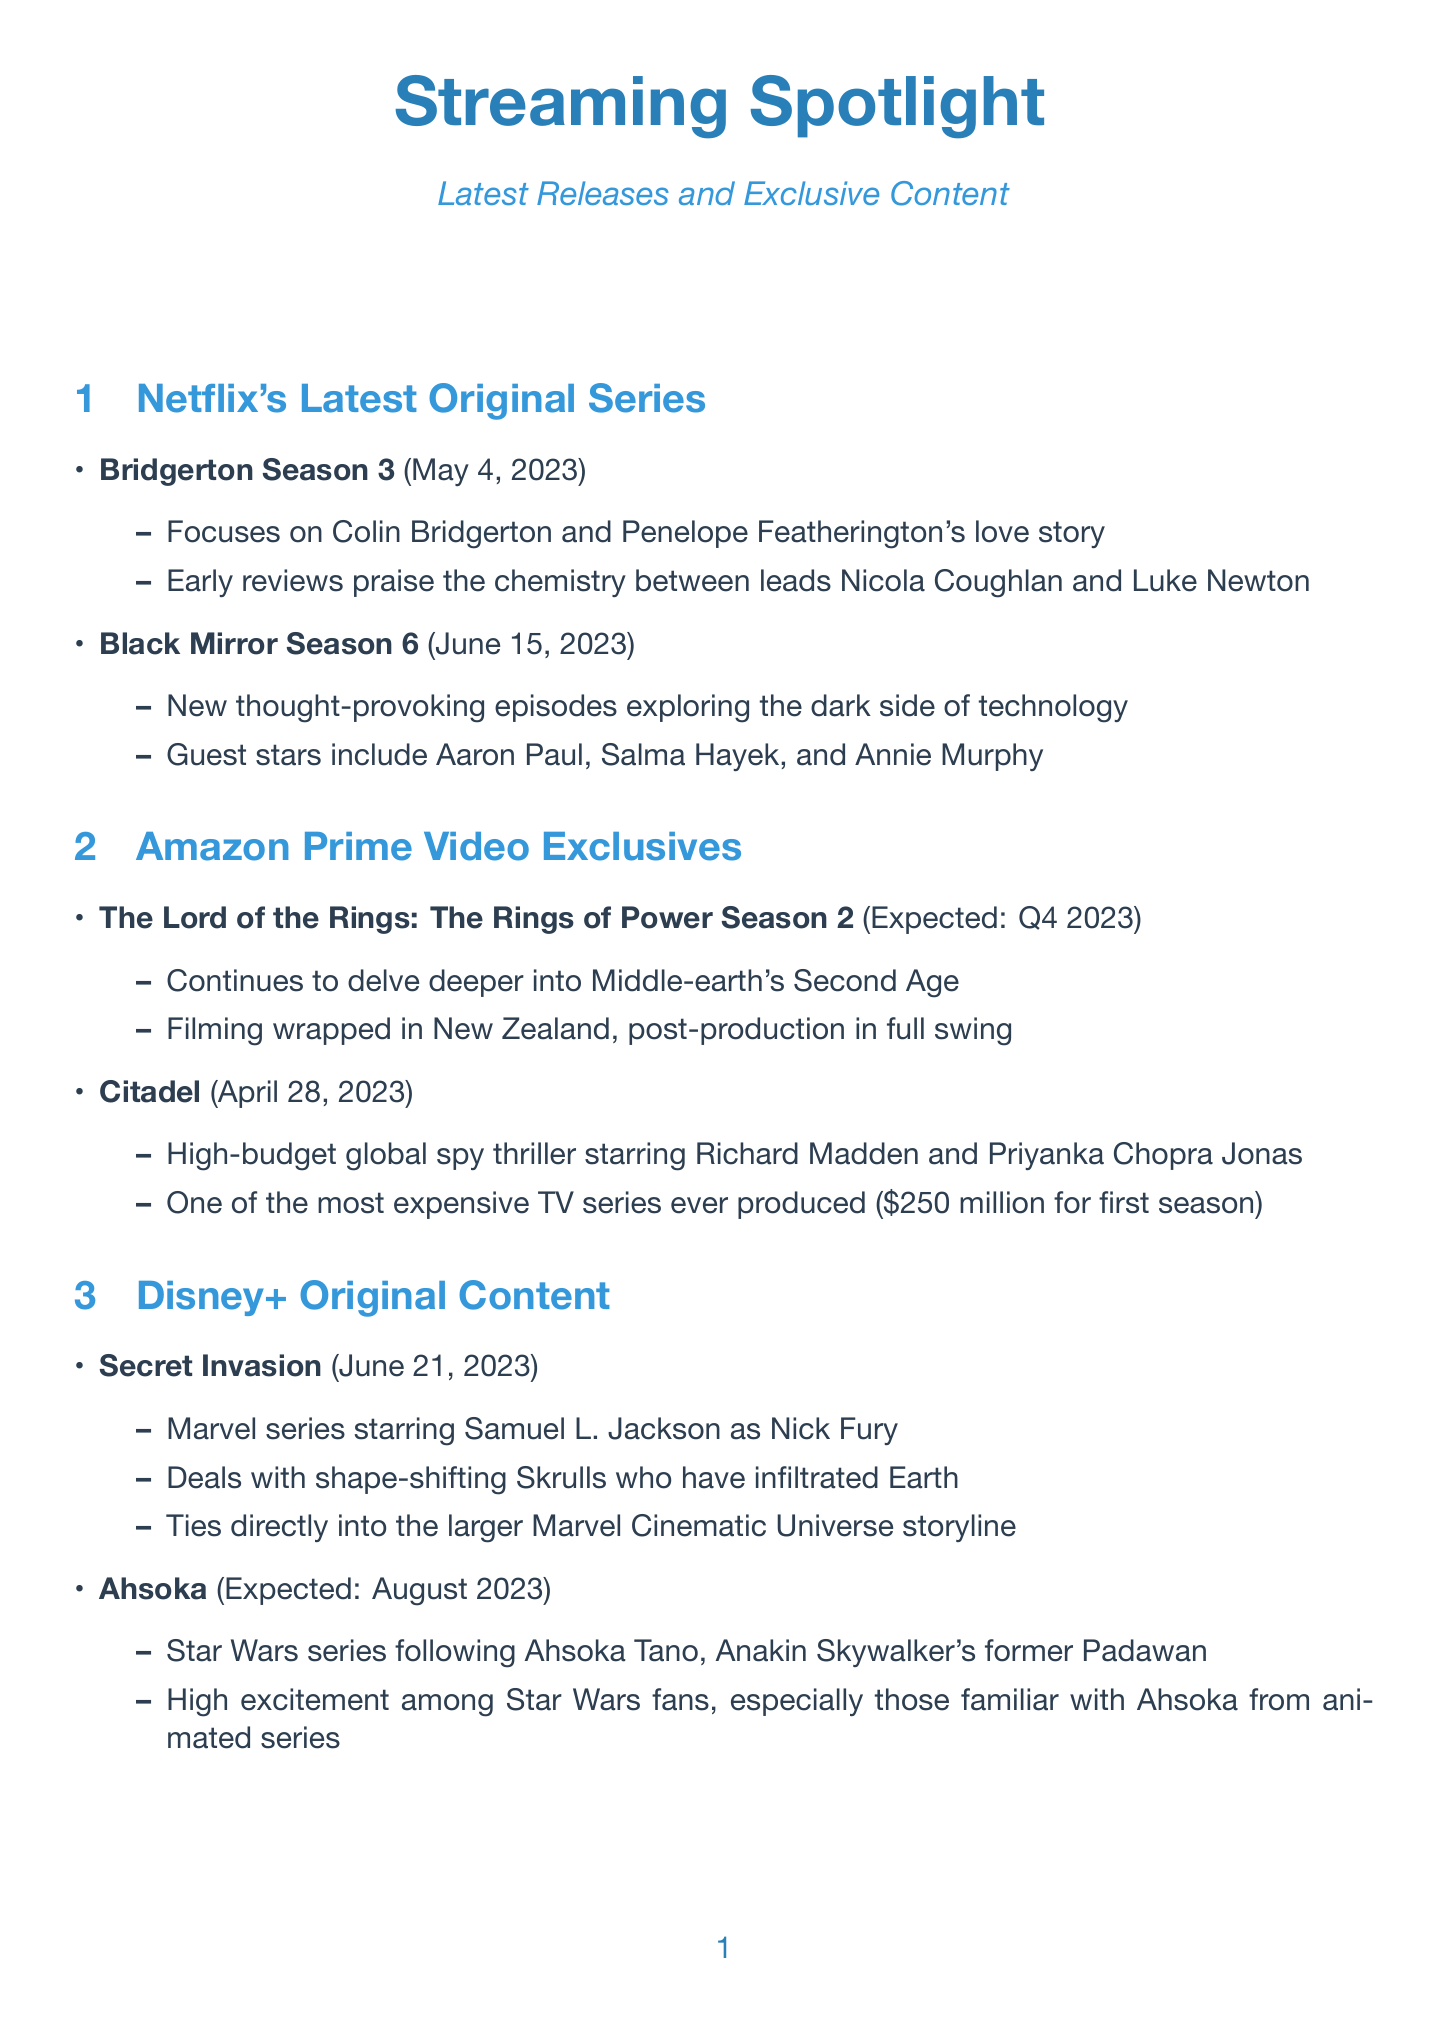What is the release date of Bridgerton Season 3? The release date for Bridgerton Season 3 is mentioned in the document as May 4, 2023.
Answer: May 4, 2023 Who stars in Citadel? The document indicates Richard Madden and Priyanka Chopra Jonas as the stars of Citadel.
Answer: Richard Madden and Priyanka Chopra Jonas What is the expected release date for The Lord of the Rings: The Rings of Power Season 2? The expected release date for the series is noted as Q4 2023 in the document.
Answer: Q4 2023 Which series features Samuel L. Jackson? The document states that Secret Invasion features Samuel L. Jackson.
Answer: Secret Invasion What notable aspect is mentioned about the budget for Citadel? The document highlights that Citadel has a reported budget of $250 million for the first season.
Answer: $250 million How does Secret Invasion connect to the MCU? It is mentioned in the document that Secret Invasion ties directly into the larger Marvel Cinematic Universe storyline.
Answer: Ties directly into the larger Marvel Cinematic Universe storyline What is a key feature of the series Hijack? The document describes Hijack as taking place over a seven-hour flight, creating real-time suspense.
Answer: Takes place over a seven-hour flight Who is the showrunner for True Detective: Night Country? The document specifies that Issa López takes over as showrunner for True Detective: Night Country.
Answer: Issa López 